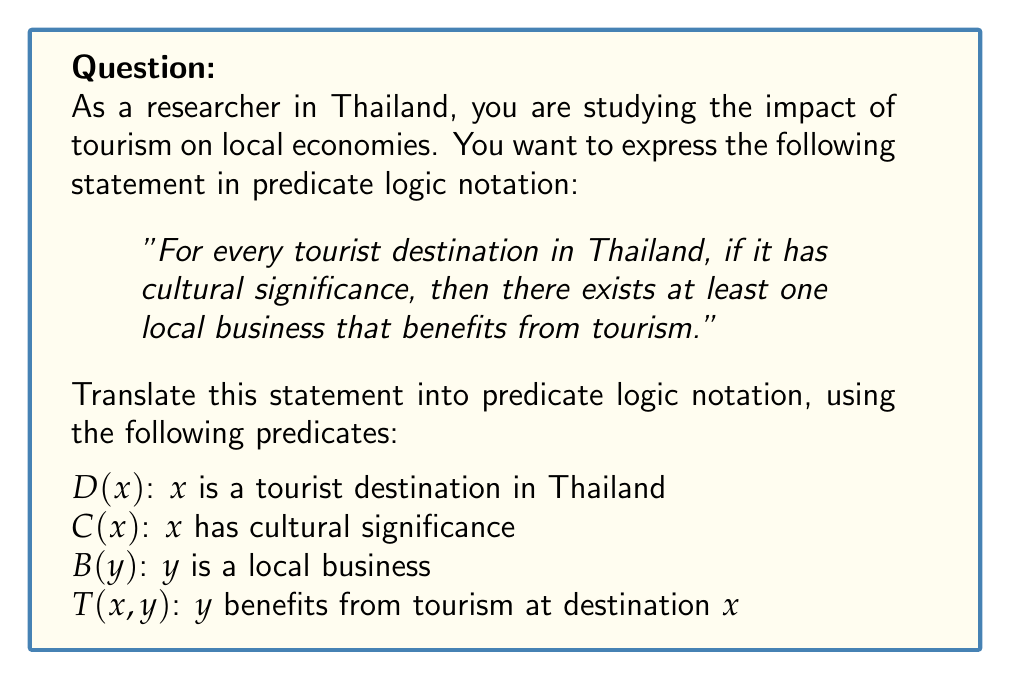Can you answer this question? To translate this statement into predicate logic notation, let's break it down step by step:

1. "For every tourist destination in Thailand" is represented by the universal quantifier $\forall x$ (for all x), where x represents a tourist destination. We also need to specify that x is a tourist destination in Thailand using the predicate $D(x)$.

2. "If it has cultural significance" is the antecedent of an implication. We represent this with $C(x)$.

3. "Then there exists at least one local business" is represented by the existential quantifier $\exists y$ (there exists a y), where y represents a local business. We need to specify that y is a local business using the predicate $B(y)$.

4. "That benefits from tourism" is represented by the predicate $T(x,y)$, which relates the tourist destination x to the local business y.

Putting these components together, we get:

$$\forall x [D(x) \rightarrow (C(x) \rightarrow \exists y (B(y) \wedge T(x,y)))]$$

This can be simplified by combining the implications:

$$\forall x [(D(x) \wedge C(x)) \rightarrow \exists y (B(y) \wedge T(x,y))]$$

This formula reads: "For all x, if x is a tourist destination in Thailand and x has cultural significance, then there exists a y such that y is a local business and y benefits from tourism at destination x."
Answer: $$\forall x [(D(x) \wedge C(x)) \rightarrow \exists y (B(y) \wedge T(x,y))]$$ 